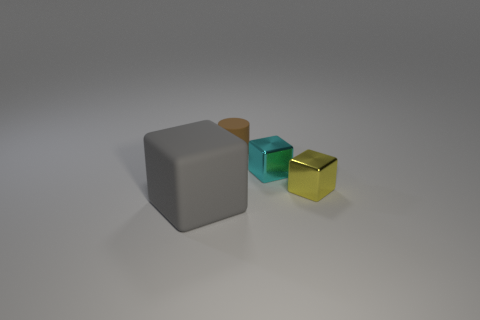Subtract all cyan cubes. How many cubes are left? 2 Add 1 small rubber things. How many objects exist? 5 Subtract all blocks. How many objects are left? 1 Add 1 large gray rubber blocks. How many large gray rubber blocks exist? 2 Subtract 0 gray cylinders. How many objects are left? 4 Subtract all gray rubber cubes. Subtract all big yellow rubber spheres. How many objects are left? 3 Add 4 tiny yellow blocks. How many tiny yellow blocks are left? 5 